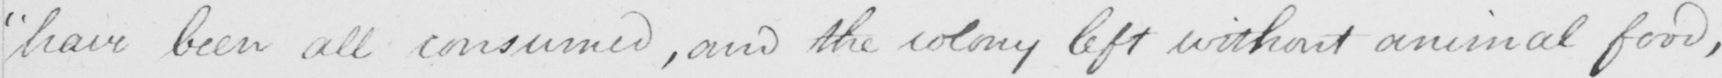Can you read and transcribe this handwriting? have been all consumed , and the colony left without animal food , 